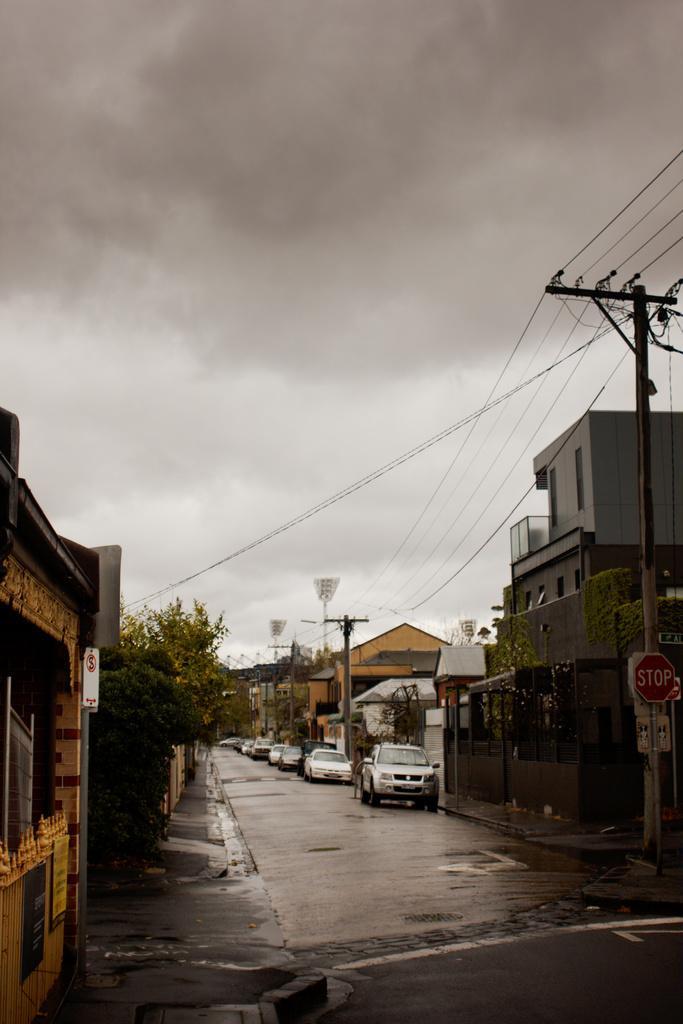Describe this image in one or two sentences. In this image I can see few vehicles on the road. I can also see few electric poles, buildings in brown and gray color, trees in green color and the sky is in white and gray color. 